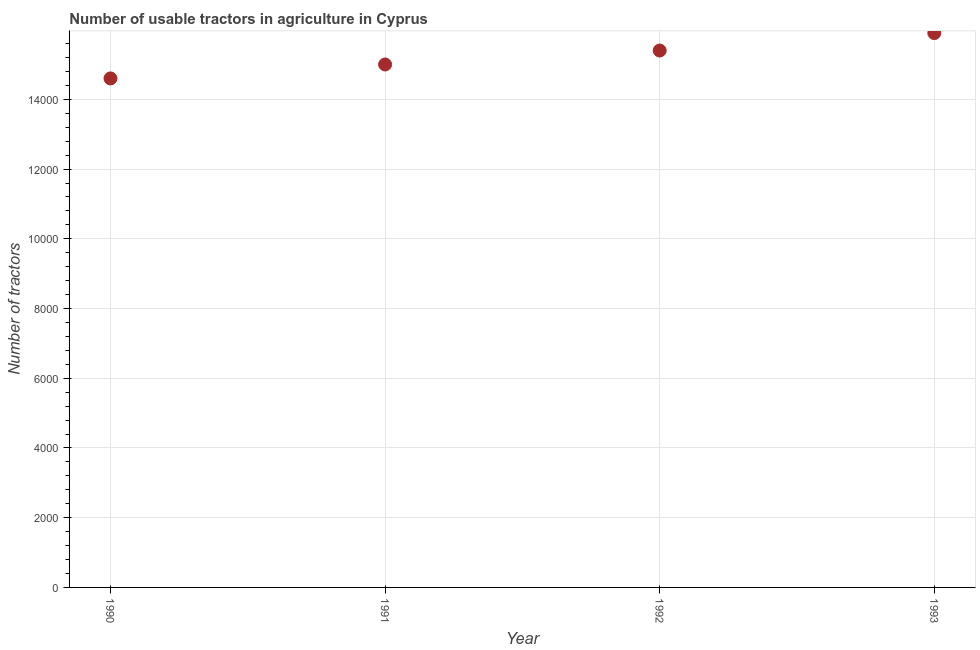What is the number of tractors in 1993?
Your answer should be compact. 1.59e+04. Across all years, what is the maximum number of tractors?
Ensure brevity in your answer.  1.59e+04. Across all years, what is the minimum number of tractors?
Your response must be concise. 1.46e+04. In which year was the number of tractors maximum?
Offer a very short reply. 1993. What is the sum of the number of tractors?
Provide a short and direct response. 6.09e+04. What is the difference between the number of tractors in 1990 and 1993?
Your answer should be very brief. -1300. What is the average number of tractors per year?
Offer a very short reply. 1.52e+04. What is the median number of tractors?
Offer a very short reply. 1.52e+04. In how many years, is the number of tractors greater than 14000 ?
Provide a short and direct response. 4. What is the ratio of the number of tractors in 1990 to that in 1993?
Your answer should be very brief. 0.92. Is the number of tractors in 1990 less than that in 1993?
Your answer should be very brief. Yes. What is the difference between the highest and the second highest number of tractors?
Make the answer very short. 500. What is the difference between the highest and the lowest number of tractors?
Offer a terse response. 1300. How many dotlines are there?
Make the answer very short. 1. How many years are there in the graph?
Offer a terse response. 4. Does the graph contain any zero values?
Keep it short and to the point. No. Does the graph contain grids?
Make the answer very short. Yes. What is the title of the graph?
Your answer should be compact. Number of usable tractors in agriculture in Cyprus. What is the label or title of the Y-axis?
Keep it short and to the point. Number of tractors. What is the Number of tractors in 1990?
Offer a very short reply. 1.46e+04. What is the Number of tractors in 1991?
Your answer should be compact. 1.50e+04. What is the Number of tractors in 1992?
Offer a very short reply. 1.54e+04. What is the Number of tractors in 1993?
Offer a very short reply. 1.59e+04. What is the difference between the Number of tractors in 1990 and 1991?
Your answer should be very brief. -400. What is the difference between the Number of tractors in 1990 and 1992?
Your answer should be very brief. -800. What is the difference between the Number of tractors in 1990 and 1993?
Give a very brief answer. -1300. What is the difference between the Number of tractors in 1991 and 1992?
Provide a short and direct response. -400. What is the difference between the Number of tractors in 1991 and 1993?
Your answer should be compact. -900. What is the difference between the Number of tractors in 1992 and 1993?
Give a very brief answer. -500. What is the ratio of the Number of tractors in 1990 to that in 1992?
Your answer should be compact. 0.95. What is the ratio of the Number of tractors in 1990 to that in 1993?
Offer a terse response. 0.92. What is the ratio of the Number of tractors in 1991 to that in 1992?
Your answer should be compact. 0.97. What is the ratio of the Number of tractors in 1991 to that in 1993?
Keep it short and to the point. 0.94. 